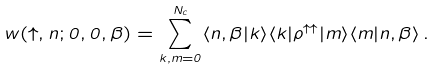<formula> <loc_0><loc_0><loc_500><loc_500>w ( \uparrow , n ; 0 , 0 , \beta ) = \sum _ { k , m = 0 } ^ { N _ { c } } \langle n , \beta | k \rangle \langle k | \rho ^ { \uparrow \uparrow } | m \rangle \langle m | n , \beta \rangle \, .</formula> 